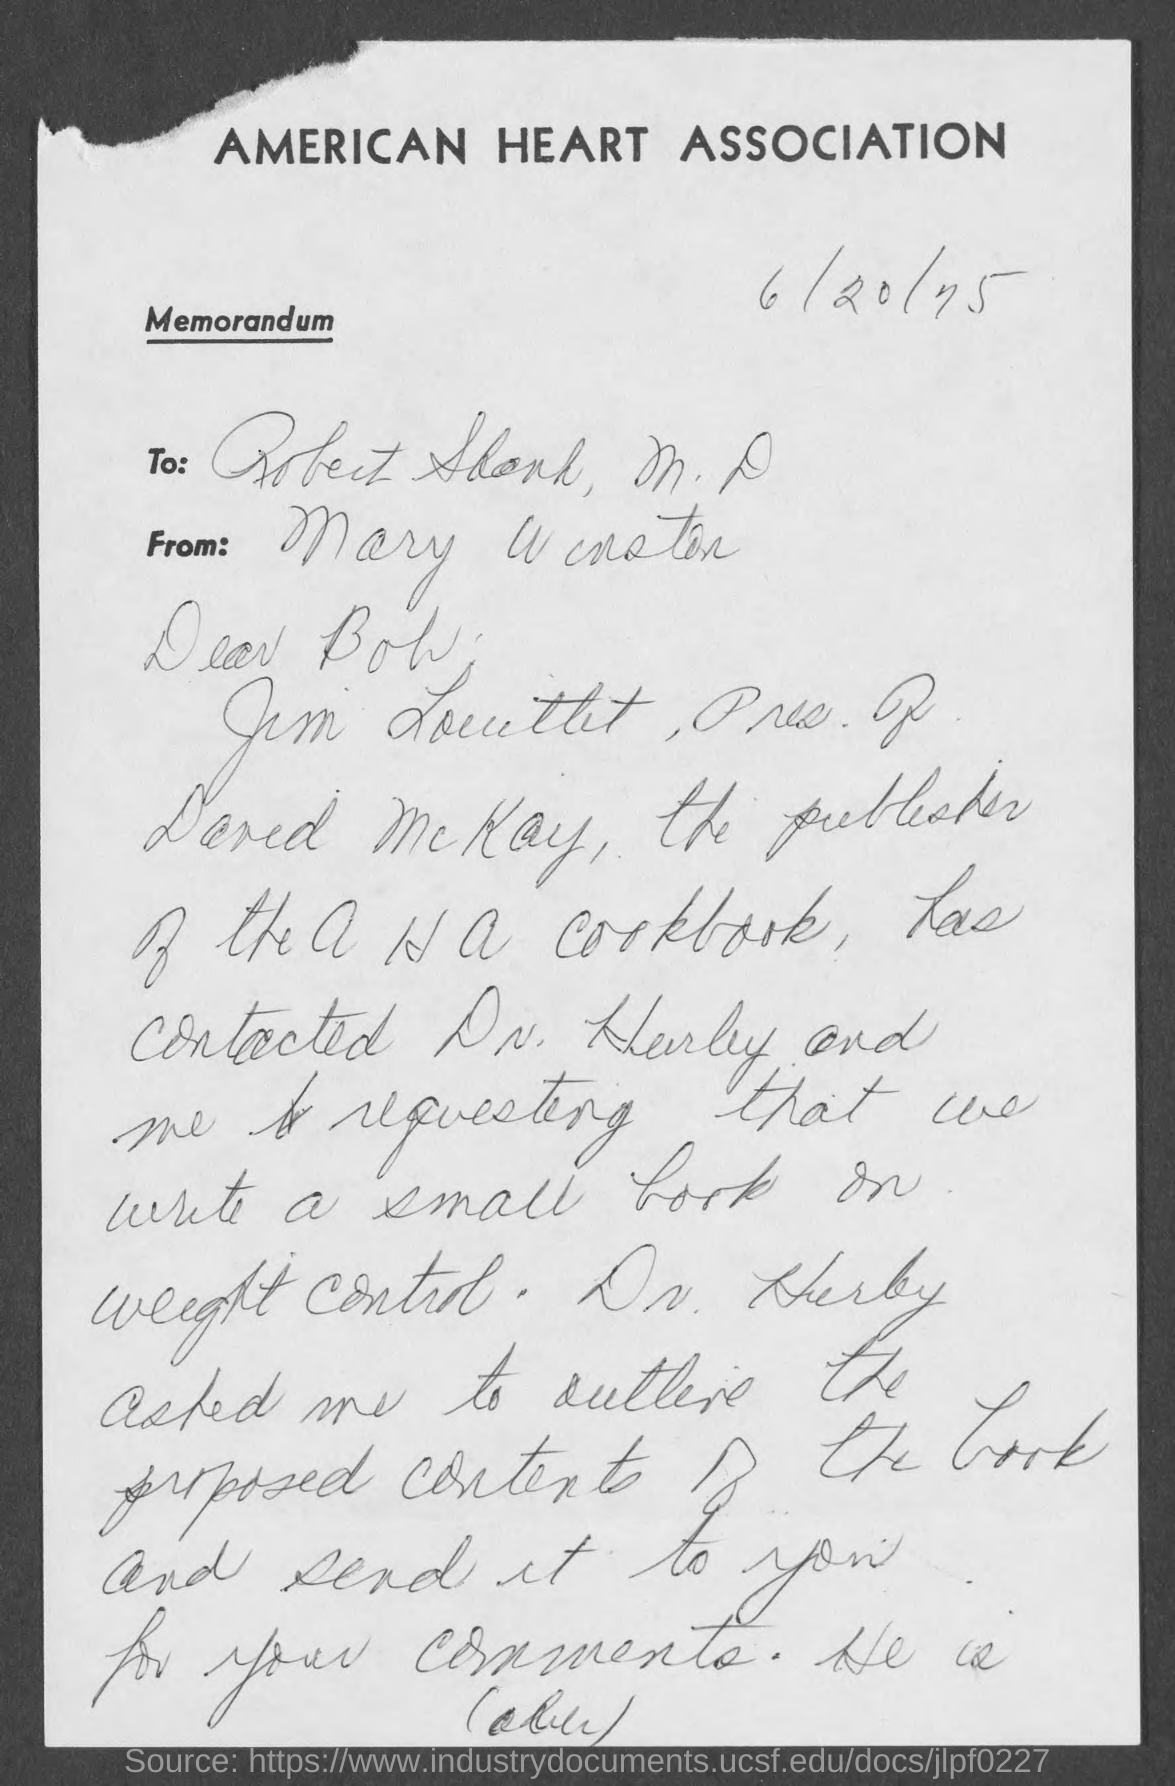Which association is mentioned?
Keep it short and to the point. AMERICAN HEART ASSOCIATION. What type of documentation is this?
Your answer should be very brief. Memorandum. 